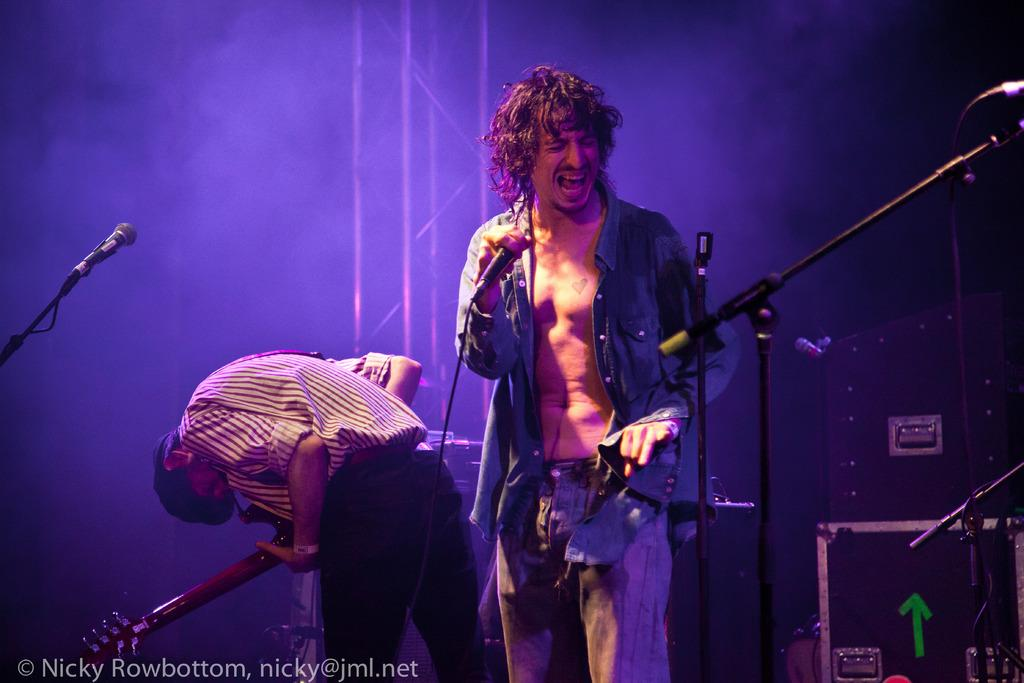What is the main activity of the person in the image? The guy in the image is singing. What object is the guy holding while singing? The guy is holding a microphone in one of his hands. What is the other person in the image doing? The man in the image is playing a guitar. What type of pig can be seen playing the guitar in the image? There is no pig present in the image, and therefore no such activity can be observed. What color are the lips of the person singing in the image? The provided facts do not mention the color of the person's lips, so it cannot be determined from the image. 